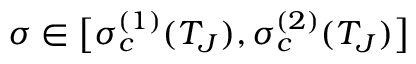<formula> <loc_0><loc_0><loc_500><loc_500>\sigma \in \left [ \sigma _ { c } ^ { ( 1 ) } ( T _ { J } ) , \sigma _ { c } ^ { ( 2 ) } ( T _ { J } ) \right ]</formula> 